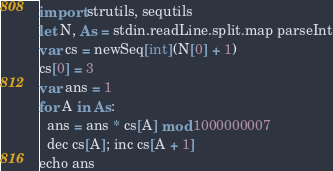Convert code to text. <code><loc_0><loc_0><loc_500><loc_500><_Nim_>import strutils, sequtils
let N, As = stdin.readLine.split.map parseInt
var cs = newSeq[int](N[0] + 1)
cs[0] = 3
var ans = 1
for A in As:
  ans = ans * cs[A] mod 1000000007
  dec cs[A]; inc cs[A + 1]
echo ans</code> 